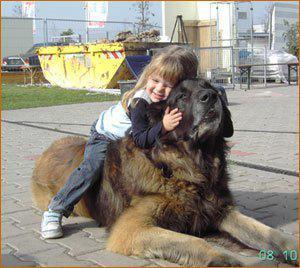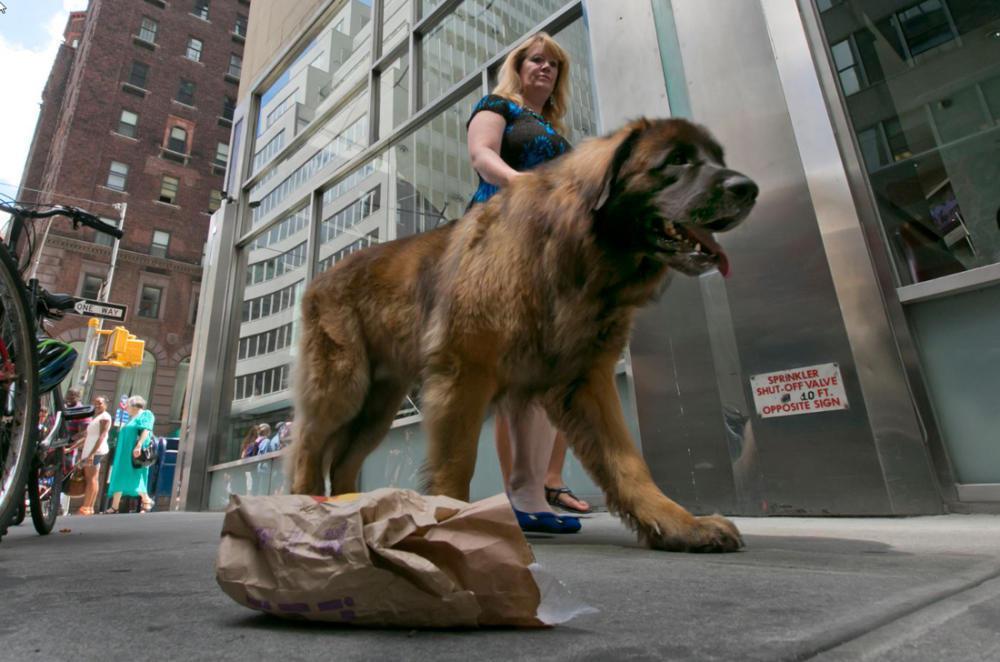The first image is the image on the left, the second image is the image on the right. Evaluate the accuracy of this statement regarding the images: "In one of the images, a human can be seen walking at least one dog.". Is it true? Answer yes or no. Yes. The first image is the image on the left, the second image is the image on the right. Assess this claim about the two images: "One image has a person standing next to a dog in the city.". Correct or not? Answer yes or no. Yes. 